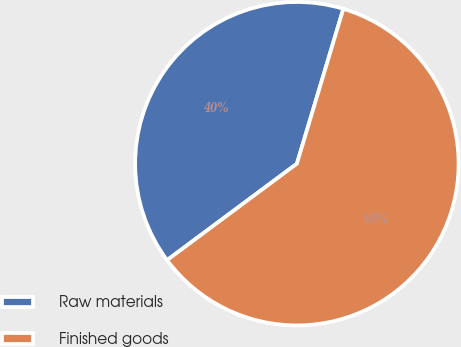<chart> <loc_0><loc_0><loc_500><loc_500><pie_chart><fcel>Raw materials<fcel>Finished goods<nl><fcel>39.81%<fcel>60.19%<nl></chart> 